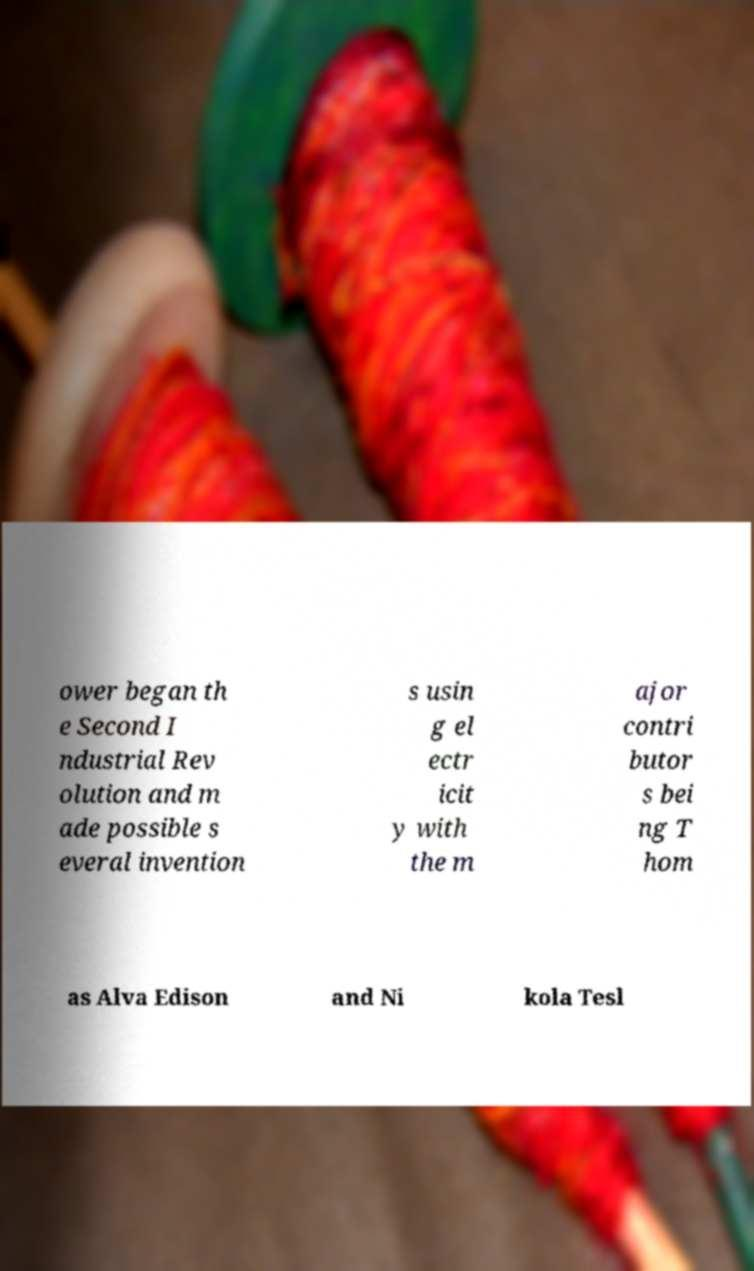For documentation purposes, I need the text within this image transcribed. Could you provide that? ower began th e Second I ndustrial Rev olution and m ade possible s everal invention s usin g el ectr icit y with the m ajor contri butor s bei ng T hom as Alva Edison and Ni kola Tesl 